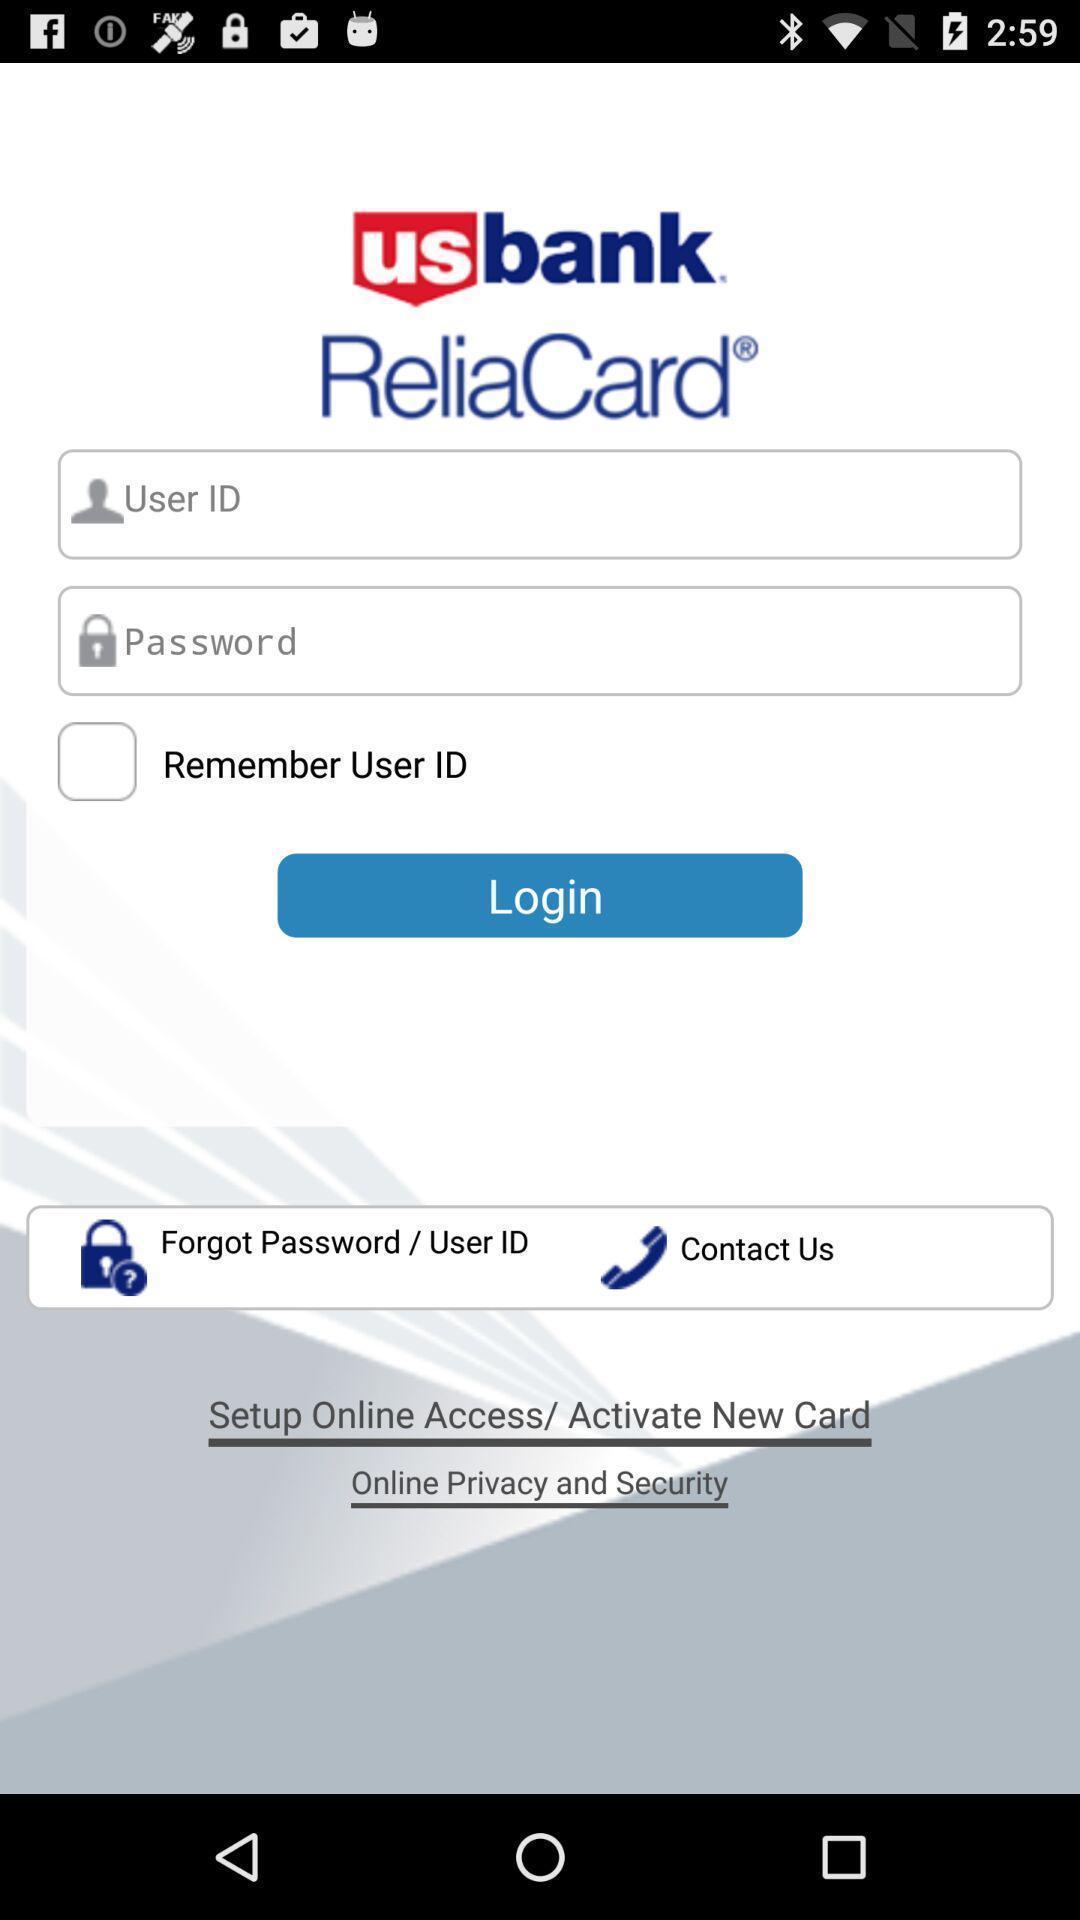Summarize the main components in this picture. Login page. 